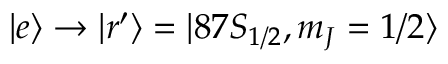<formula> <loc_0><loc_0><loc_500><loc_500>| e \rangle \rightarrow | r ^ { \prime } \rangle = | 8 7 S _ { 1 / 2 } , m _ { J } = 1 / 2 \rangle</formula> 